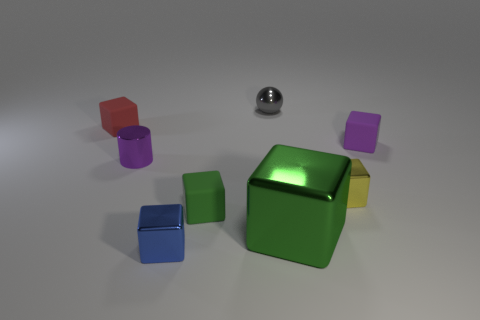What materials are the objects in the image made of? The objects in the image seem to be made of different kinds of materials. The sphere has a shiny, reflective surface suggestive of metal. The cubes, on the other hand, have a matte finish which could imitate materials like plastic or painted wood. 